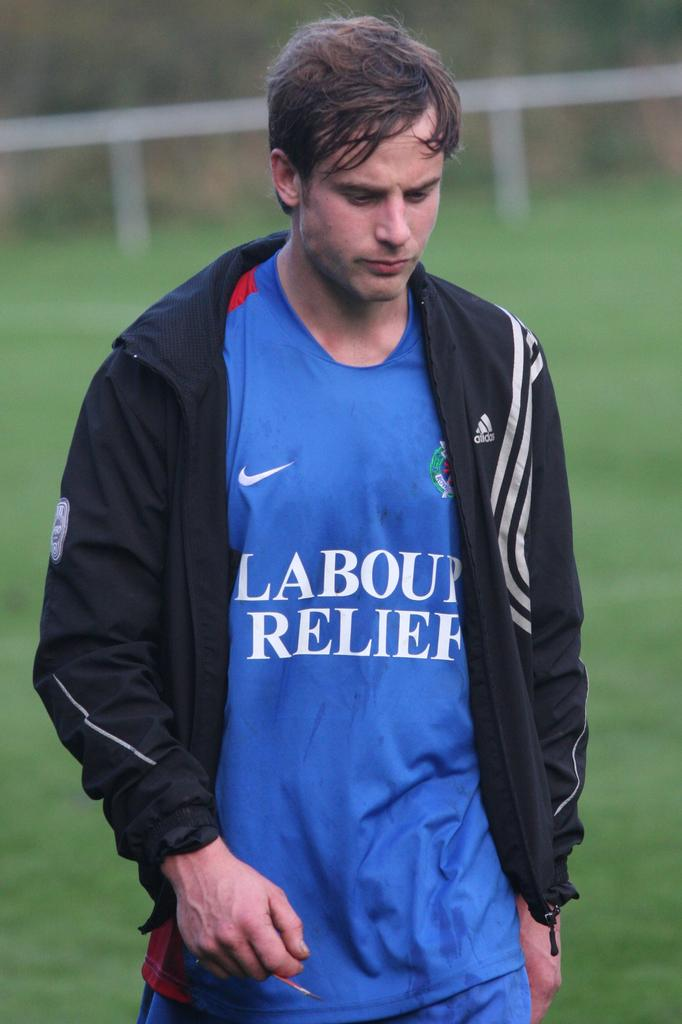<image>
Describe the image concisely. The word relief appears on a guy's shirt. 